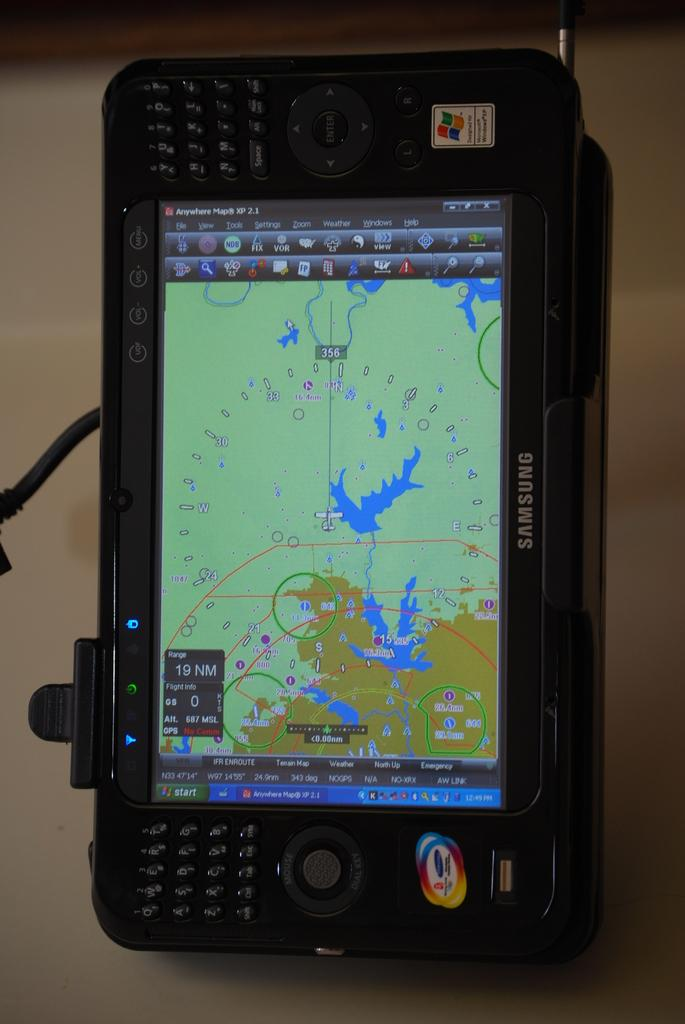<image>
Provide a brief description of the given image. A Samsung gps is displaying the anywhere maps app 